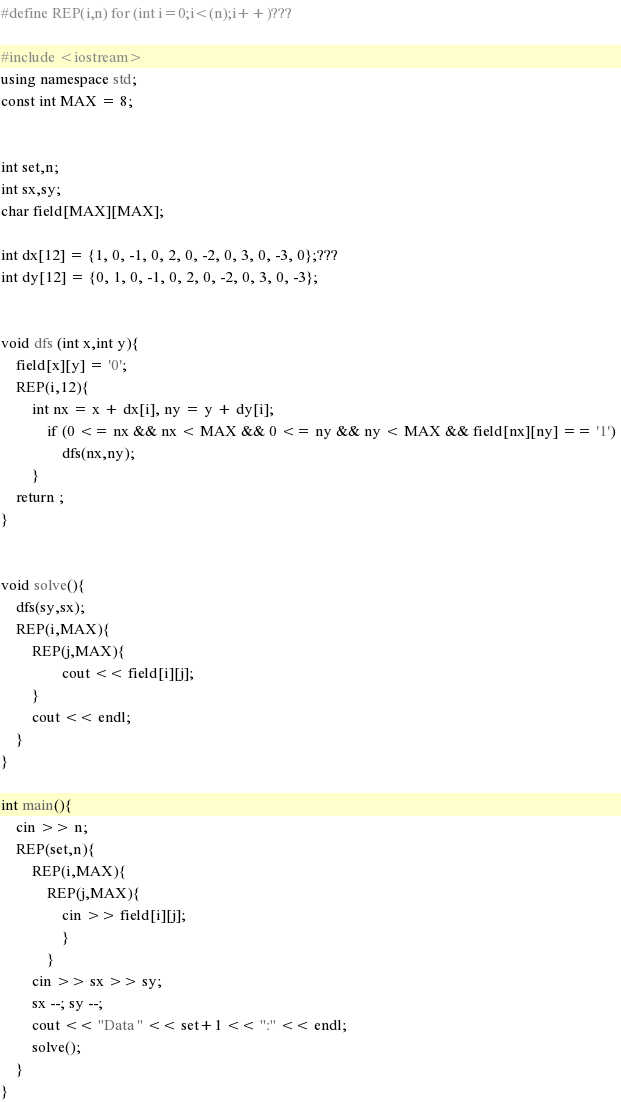<code> <loc_0><loc_0><loc_500><loc_500><_C++_>#define REP(i,n) for (int i=0;i<(n);i++)???

#include <iostream>
using namespace std;
const int MAX = 8;


int set,n;
int sx,sy;
char field[MAX][MAX];

int dx[12] = {1, 0, -1, 0, 2, 0, -2, 0, 3, 0, -3, 0};???
int dy[12] = {0, 1, 0, -1, 0, 2, 0, -2, 0, 3, 0, -3};


void dfs (int x,int y){
	field[x][y] = '0';
	REP(i,12){
		int nx = x + dx[i], ny = y + dy[i];
			if (0 <= nx && nx < MAX && 0 <= ny && ny < MAX && field[nx][ny] == '1') 
				dfs(nx,ny);
		}
	return ;
}


void solve(){
	dfs(sy,sx);
	REP(i,MAX){
		REP(j,MAX){
				cout << field[i][j];
		}
		cout << endl;
	}
}

int main(){
	cin >> n;
	REP(set,n){
		REP(i,MAX){
			REP(j,MAX){
				cin >> field[i][j];
				}
			}
		cin >> sx >> sy;
		sx --; sy --;
		cout << "Data " << set+1 << ":" << endl;
		solve();
	}
}</code> 